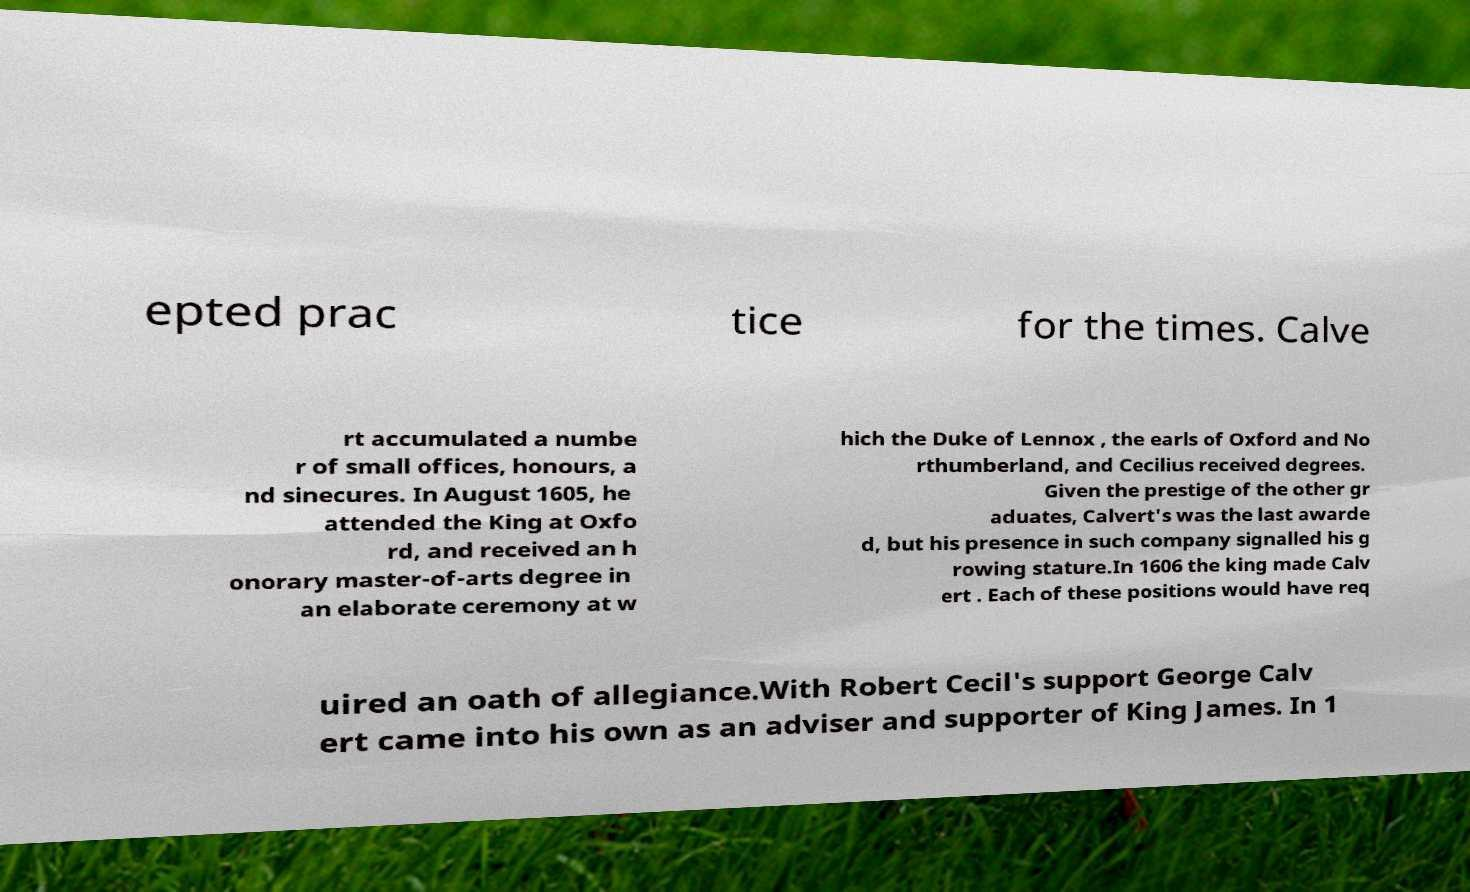What messages or text are displayed in this image? I need them in a readable, typed format. epted prac tice for the times. Calve rt accumulated a numbe r of small offices, honours, a nd sinecures. In August 1605, he attended the King at Oxfo rd, and received an h onorary master-of-arts degree in an elaborate ceremony at w hich the Duke of Lennox , the earls of Oxford and No rthumberland, and Cecilius received degrees. Given the prestige of the other gr aduates, Calvert's was the last awarde d, but his presence in such company signalled his g rowing stature.In 1606 the king made Calv ert . Each of these positions would have req uired an oath of allegiance.With Robert Cecil's support George Calv ert came into his own as an adviser and supporter of King James. In 1 